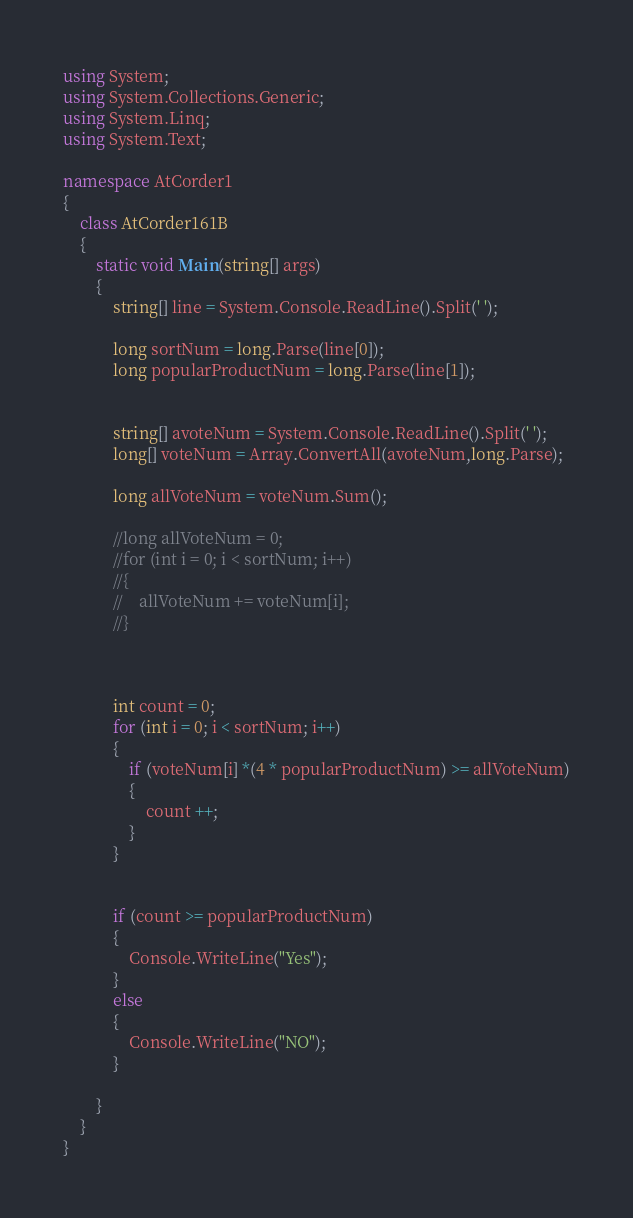Convert code to text. <code><loc_0><loc_0><loc_500><loc_500><_C#_>using System;
using System.Collections.Generic;
using System.Linq;
using System.Text;

namespace AtCorder1
{
    class AtCorder161B
    {
        static void Main(string[] args)
        {
            string[] line = System.Console.ReadLine().Split(' ');

            long sortNum = long.Parse(line[0]);
            long popularProductNum = long.Parse(line[1]);


            string[] avoteNum = System.Console.ReadLine().Split(' ');
            long[] voteNum = Array.ConvertAll(avoteNum,long.Parse);

            long allVoteNum = voteNum.Sum();

            //long allVoteNum = 0;
            //for (int i = 0; i < sortNum; i++)
            //{
            //    allVoteNum += voteNum[i];
            //}

            

            int count = 0;         
            for (int i = 0; i < sortNum; i++)
            {
                if (voteNum[i] *(4 * popularProductNum) >= allVoteNum)
                {
                    count ++;
                }
            }


            if (count >= popularProductNum)
            {
                Console.WriteLine("Yes");
            }
            else
            {
                Console.WriteLine("NO");
            }

        }
    }
}
</code> 